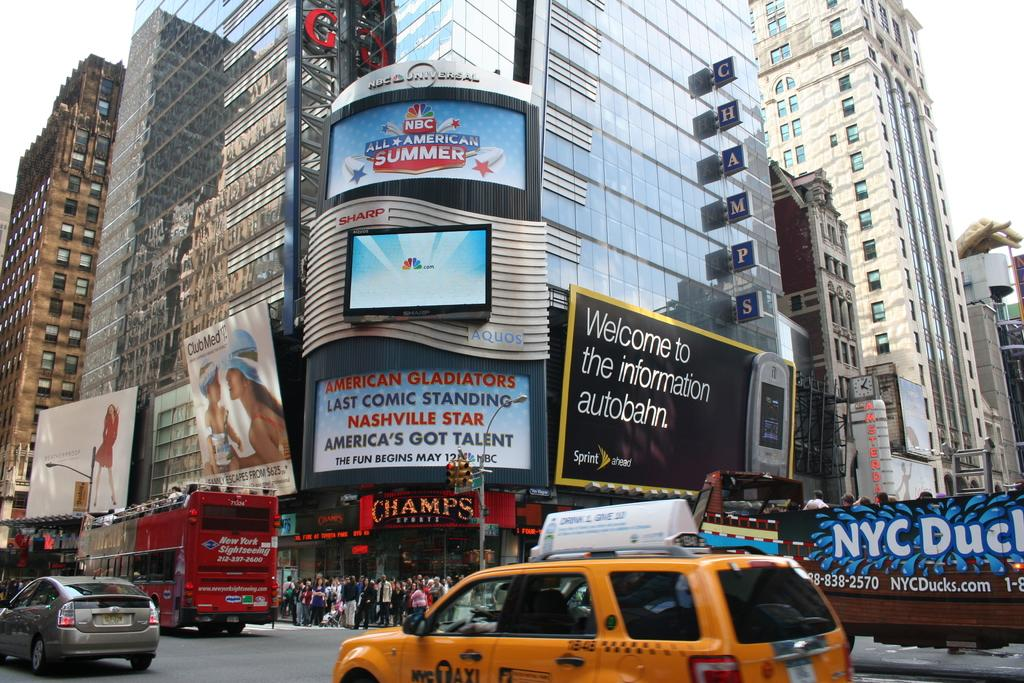<image>
Relay a brief, clear account of the picture shown. In a crowded city neighborhood, a Sprint billboard refers to the Information Autobahn. 